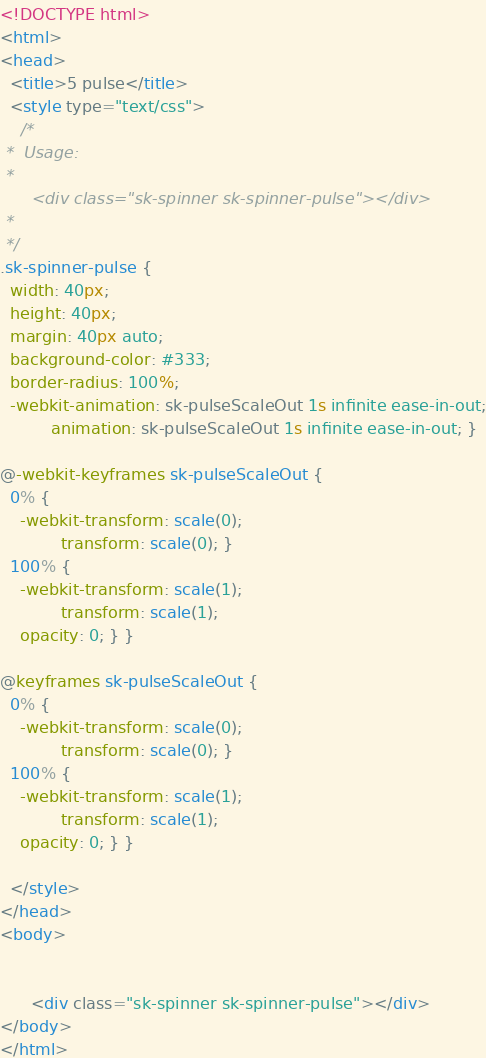Convert code to text. <code><loc_0><loc_0><loc_500><loc_500><_HTML_><!DOCTYPE html>
<html>
<head>
  <title>5 pulse</title>
  <style type="text/css">
    /*
 *  Usage:
 *
      <div class="sk-spinner sk-spinner-pulse"></div>
 *
 */
.sk-spinner-pulse {
  width: 40px;
  height: 40px;
  margin: 40px auto;
  background-color: #333;
  border-radius: 100%;
  -webkit-animation: sk-pulseScaleOut 1s infinite ease-in-out;
          animation: sk-pulseScaleOut 1s infinite ease-in-out; }

@-webkit-keyframes sk-pulseScaleOut {
  0% {
    -webkit-transform: scale(0);
            transform: scale(0); }
  100% {
    -webkit-transform: scale(1);
            transform: scale(1);
    opacity: 0; } }

@keyframes sk-pulseScaleOut {
  0% {
    -webkit-transform: scale(0);
            transform: scale(0); }
  100% {
    -webkit-transform: scale(1);
            transform: scale(1);
    opacity: 0; } }

  </style>
</head>
<body>
 

      <div class="sk-spinner sk-spinner-pulse"></div>
</body>
</html></code> 